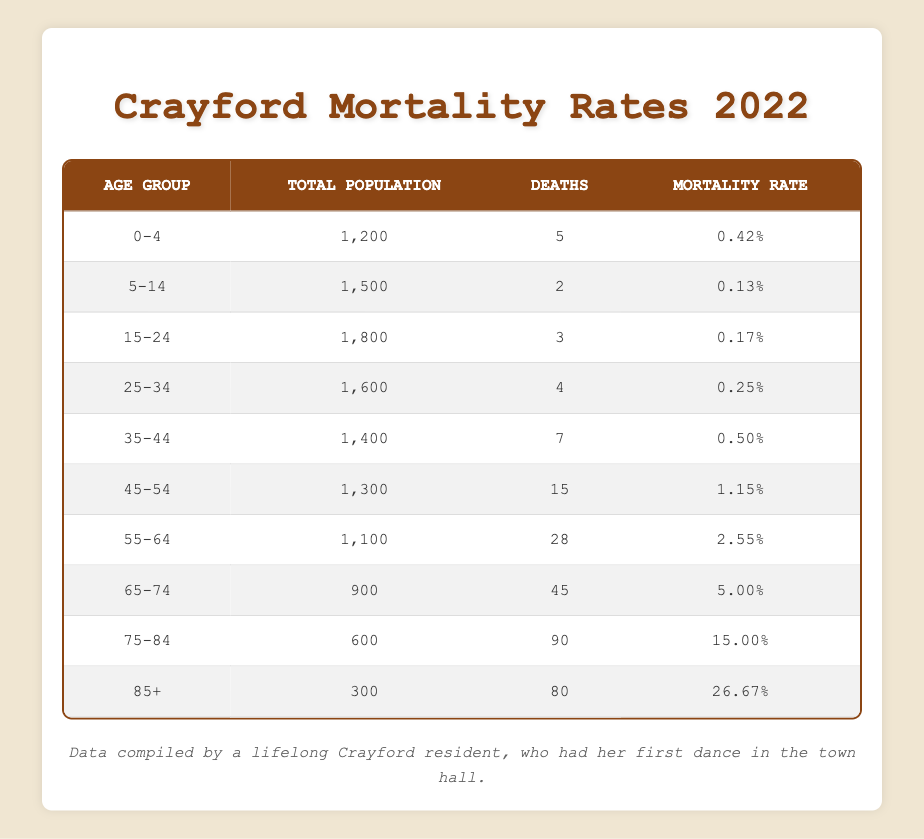What is the mortality rate for the age group 0-4? The table shows that for the age group 0-4, the Mortality Rate is listed directly as 0.0042, which is expressed as 0.42% in the table.
Answer: 0.0042 How many total deaths occurred in the age group 75-84? According to the table, there are 90 deaths reported for the age group 75-84.
Answer: 90 Which age group has the highest mortality rate? By examining the rates in the table, it's clear that the age group 85+ has the highest Mortality Rate of 0.2667, equivalent to 26.67%.
Answer: 85+ What is the total number of deaths for all age groups? To find the total number of deaths, add the deaths across all age groups: 5 + 2 + 3 + 4 + 7 + 15 + 28 + 45 + 90 + 80 = 274.
Answer: 274 Is the mortality rate for the age group 55-64 greater than that for the 45-54 age group? The Mortality Rate for 55-64 is 0.0255 (2.55%) and for 45-54 is 0.0115 (1.15%). Since 0.0255 is greater than 0.0115, the statement is true.
Answer: Yes What is the average mortality rate across all age groups? To calculate the average mortality rate, sum all the mortality rates: (0.0042 + 0.0013 + 0.0017 + 0.0025 + 0.0050 + 0.0115 + 0.0255 + 0.0500 + 0.1500 + 0.2667) = 0.4531. Then divide by the number of age groups (10): 0.4531 / 10 = 0.04531.
Answer: 0.04531 Are there more deaths in the age group 65-74 or 55-64? The table indicates there are 45 deaths in the 65-74 age group and 28 deaths in the 55-64 age group. Comparing these numbers, 45 is greater than 28, so the statement is true.
Answer: Yes What is the percentage of total population represented by deaths in the age group 45-54? The total population in the age group 45-54 is 1300 and there were 15 deaths. To find the percentage, use the formula: (15 / 1300) * 100 = 1.15%.
Answer: 1.15% 